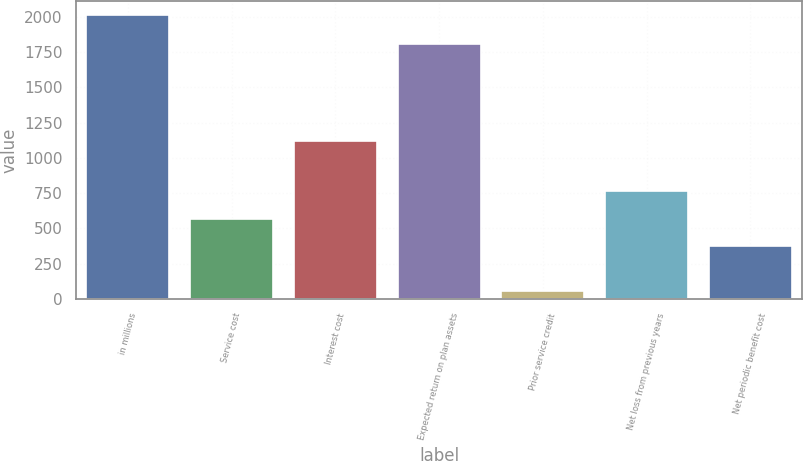<chart> <loc_0><loc_0><loc_500><loc_500><bar_chart><fcel>in millions<fcel>Service cost<fcel>Interest cost<fcel>Expected return on plan assets<fcel>Prior service credit<fcel>Net loss from previous years<fcel>Net periodic benefit cost<nl><fcel>2013<fcel>569.5<fcel>1117<fcel>1809<fcel>58<fcel>765<fcel>374<nl></chart> 